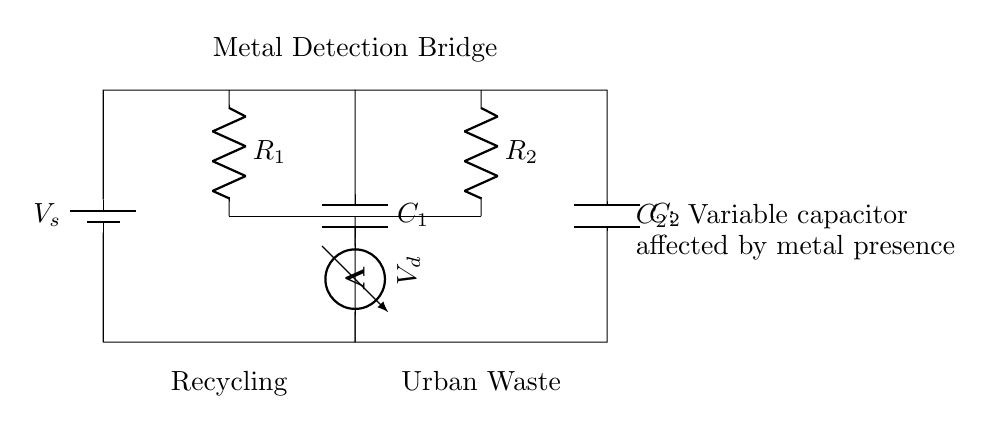What type of circuit is represented in the diagram? The circuit is a capacitive bridge circuit designed for detecting metal objects. This can be inferred from the labeling and configuration of the components, particularly the variable capacitor.
Answer: Capacitive bridge What components are in the circuit? The components in the circuit include a battery, two capacitors, two resistors, and a voltmeter. By examining the labels on each component in the diagram, we can identify them clearly.
Answer: Battery, capacitors, resistors, voltmeter What does the variable capacitor indicate? The variable capacitor, labeled as C2, indicates that its capacitance changes when metal objects are near, affecting the circuit's balance. This can be inferred from the note attached to it about metal presence affecting its value.
Answer: Metal presence What is the function of the resistors in this circuit? The resistors, labeled as R1 and R2, are used to create a voltage divider, which helps in measuring the voltage difference across the bridge. This is determined by analyzing the position and connections of the resistors in relation to the capacitors.
Answer: Voltage divider What happens to the voltage across the voltmeter if metal is detected? When metal is detected, the capacitance of C2 changes, which unbalances the bridge and alters the voltage measured by the voltmeter. This reasoning stems from understanding how capacitive and conductive properties of materials interact in a bridge circuit.
Answer: Voltage changes What does the "Metal Detection Bridge" label signify? The label “Metal Detection Bridge” signifies that the primary purpose of this circuit is to detect the presence of metal objects, as indicated by the arrangement of components intended for this function.
Answer: Metal detection purpose 